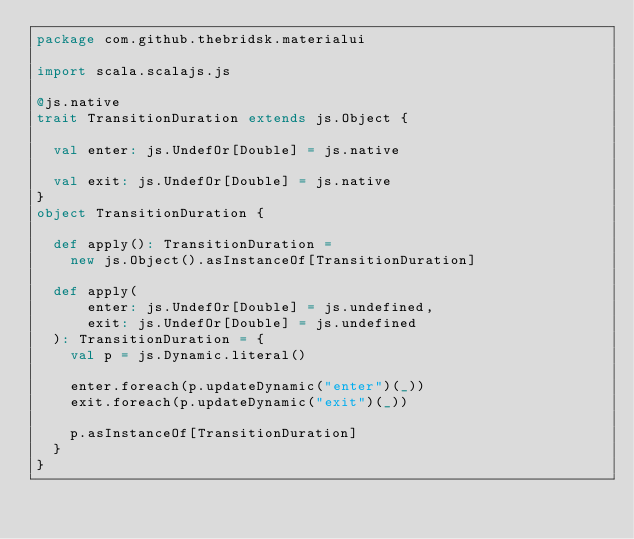<code> <loc_0><loc_0><loc_500><loc_500><_Scala_>package com.github.thebridsk.materialui

import scala.scalajs.js

@js.native
trait TransitionDuration extends js.Object {

  val enter: js.UndefOr[Double] = js.native

  val exit: js.UndefOr[Double] = js.native
}
object TransitionDuration {

  def apply(): TransitionDuration =
    new js.Object().asInstanceOf[TransitionDuration]

  def apply(
      enter: js.UndefOr[Double] = js.undefined,
      exit: js.UndefOr[Double] = js.undefined
  ): TransitionDuration = {
    val p = js.Dynamic.literal()

    enter.foreach(p.updateDynamic("enter")(_))
    exit.foreach(p.updateDynamic("exit")(_))

    p.asInstanceOf[TransitionDuration]
  }
}
</code> 